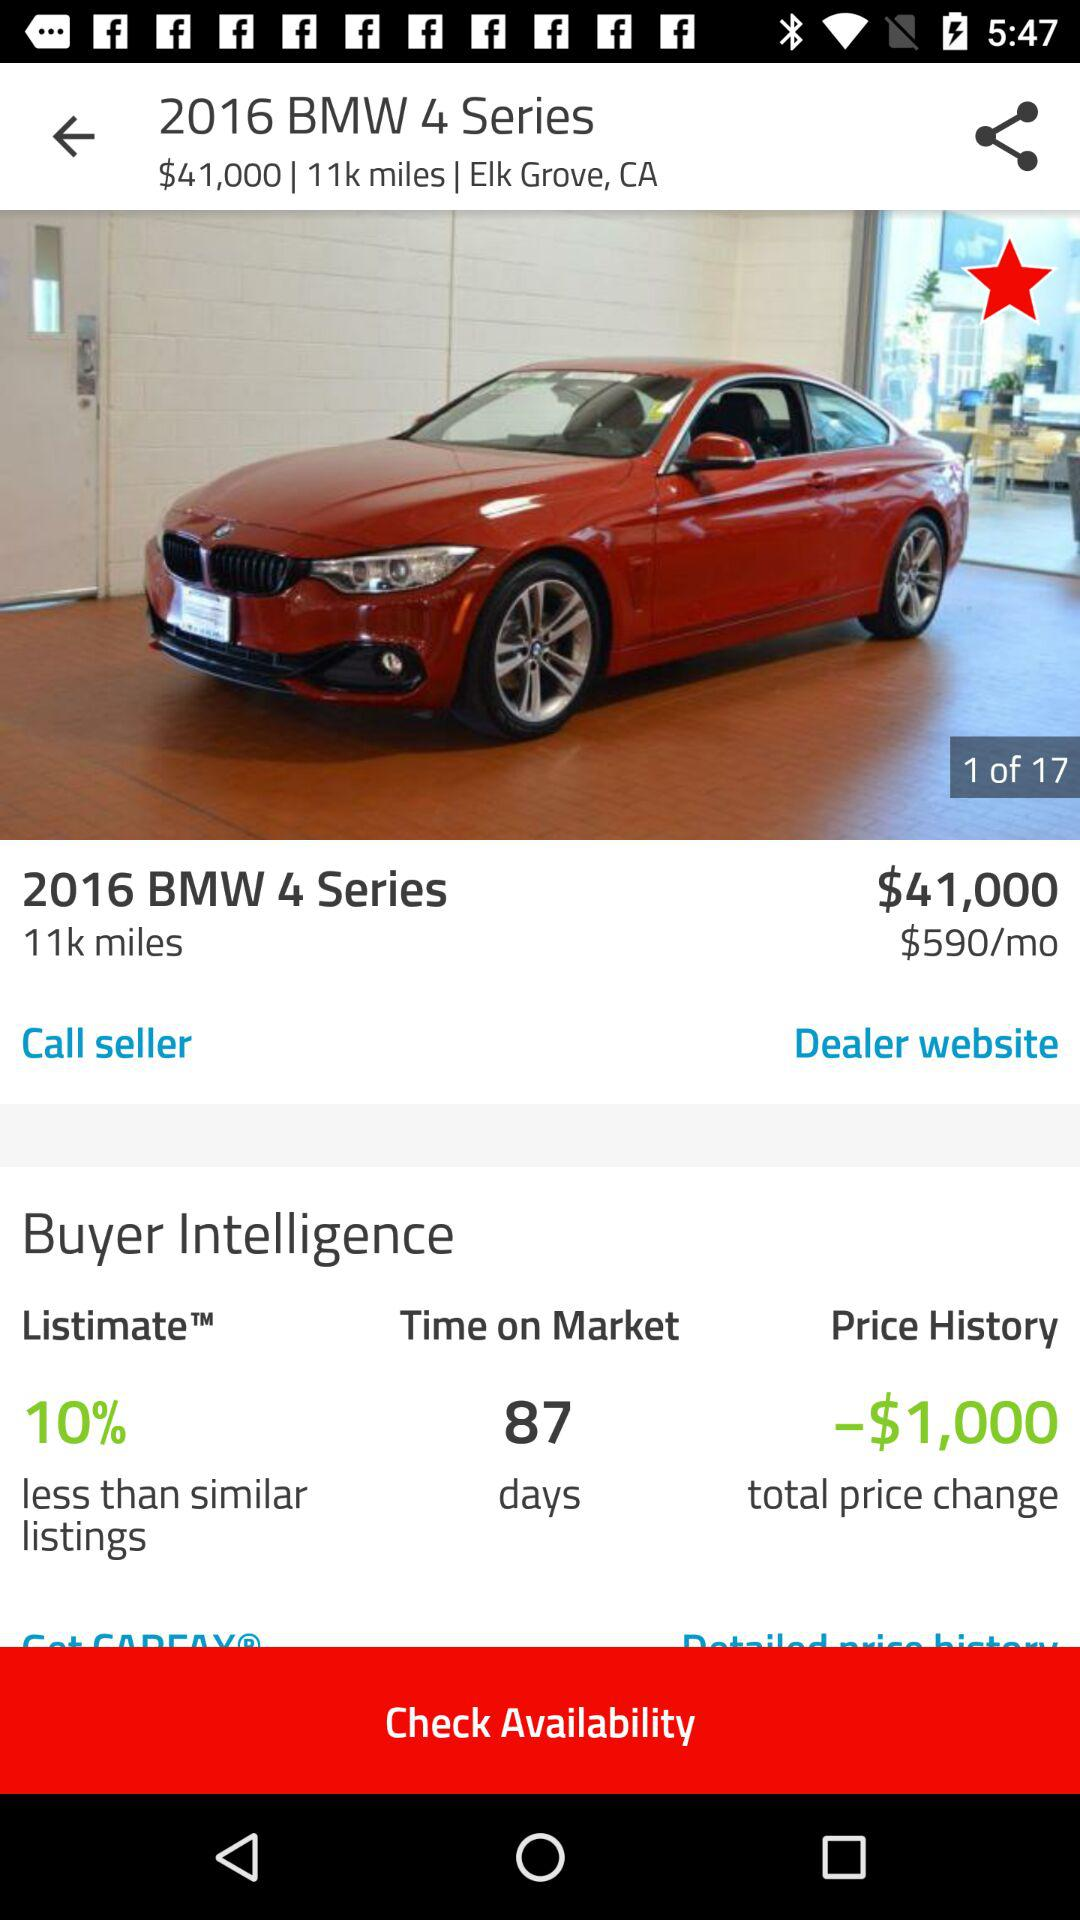What is the cost of the car? The cost of the car is $41,000. 